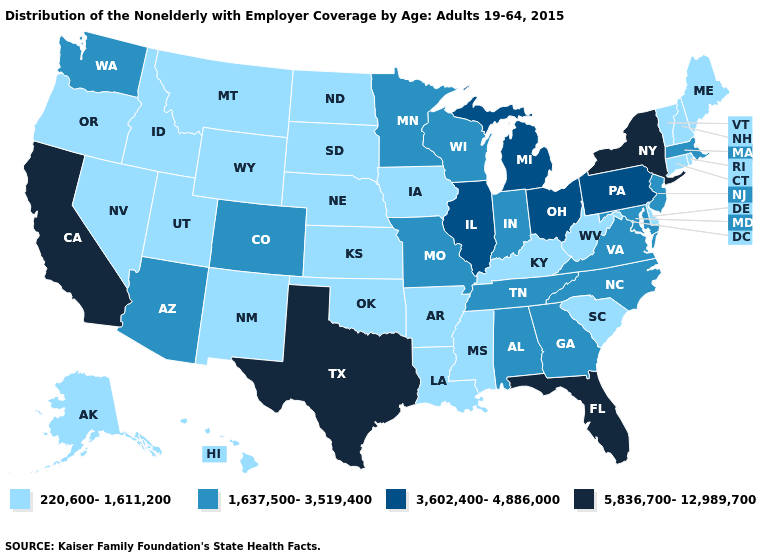What is the value of Vermont?
Short answer required. 220,600-1,611,200. Does New Mexico have the highest value in the West?
Keep it brief. No. Name the states that have a value in the range 1,637,500-3,519,400?
Answer briefly. Alabama, Arizona, Colorado, Georgia, Indiana, Maryland, Massachusetts, Minnesota, Missouri, New Jersey, North Carolina, Tennessee, Virginia, Washington, Wisconsin. What is the lowest value in the USA?
Write a very short answer. 220,600-1,611,200. What is the value of Kansas?
Answer briefly. 220,600-1,611,200. What is the lowest value in states that border Connecticut?
Keep it brief. 220,600-1,611,200. What is the highest value in the USA?
Short answer required. 5,836,700-12,989,700. What is the value of Kentucky?
Write a very short answer. 220,600-1,611,200. What is the lowest value in the USA?
Concise answer only. 220,600-1,611,200. What is the lowest value in states that border Massachusetts?
Write a very short answer. 220,600-1,611,200. Which states have the lowest value in the South?
Write a very short answer. Arkansas, Delaware, Kentucky, Louisiana, Mississippi, Oklahoma, South Carolina, West Virginia. Which states hav the highest value in the MidWest?
Give a very brief answer. Illinois, Michigan, Ohio. Does Illinois have a higher value than Virginia?
Concise answer only. Yes. Name the states that have a value in the range 1,637,500-3,519,400?
Write a very short answer. Alabama, Arizona, Colorado, Georgia, Indiana, Maryland, Massachusetts, Minnesota, Missouri, New Jersey, North Carolina, Tennessee, Virginia, Washington, Wisconsin. 